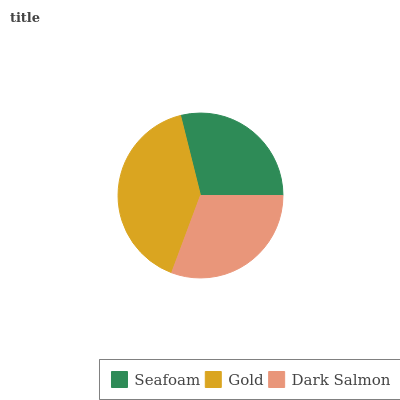Is Seafoam the minimum?
Answer yes or no. Yes. Is Gold the maximum?
Answer yes or no. Yes. Is Dark Salmon the minimum?
Answer yes or no. No. Is Dark Salmon the maximum?
Answer yes or no. No. Is Gold greater than Dark Salmon?
Answer yes or no. Yes. Is Dark Salmon less than Gold?
Answer yes or no. Yes. Is Dark Salmon greater than Gold?
Answer yes or no. No. Is Gold less than Dark Salmon?
Answer yes or no. No. Is Dark Salmon the high median?
Answer yes or no. Yes. Is Dark Salmon the low median?
Answer yes or no. Yes. Is Seafoam the high median?
Answer yes or no. No. Is Gold the low median?
Answer yes or no. No. 